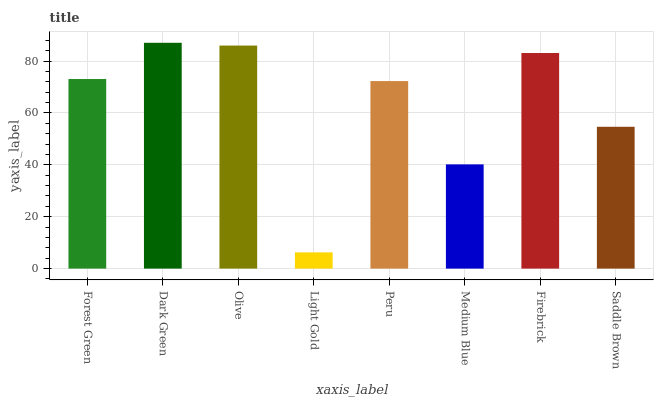Is Light Gold the minimum?
Answer yes or no. Yes. Is Dark Green the maximum?
Answer yes or no. Yes. Is Olive the minimum?
Answer yes or no. No. Is Olive the maximum?
Answer yes or no. No. Is Dark Green greater than Olive?
Answer yes or no. Yes. Is Olive less than Dark Green?
Answer yes or no. Yes. Is Olive greater than Dark Green?
Answer yes or no. No. Is Dark Green less than Olive?
Answer yes or no. No. Is Forest Green the high median?
Answer yes or no. Yes. Is Peru the low median?
Answer yes or no. Yes. Is Firebrick the high median?
Answer yes or no. No. Is Forest Green the low median?
Answer yes or no. No. 